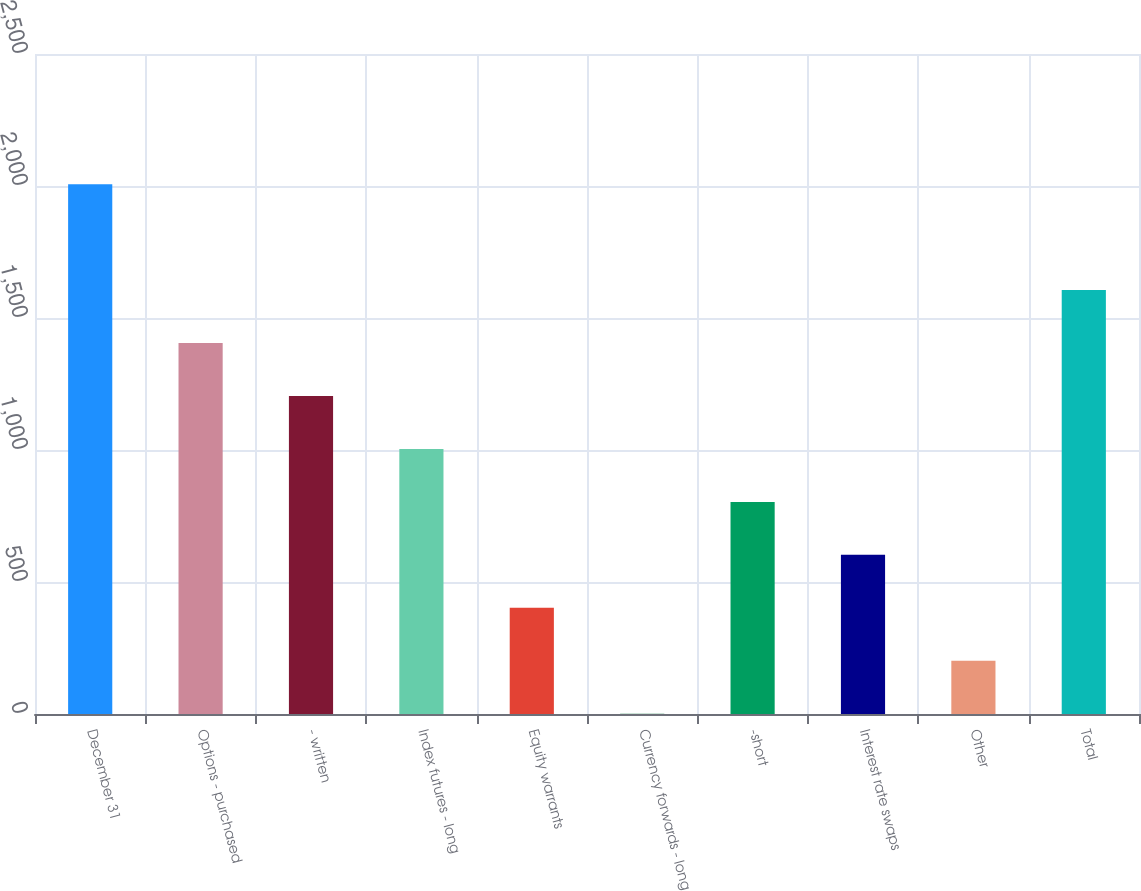Convert chart to OTSL. <chart><loc_0><loc_0><loc_500><loc_500><bar_chart><fcel>December 31<fcel>Options - purchased<fcel>- written<fcel>Index futures - long<fcel>Equity warrants<fcel>Currency forwards - long<fcel>-short<fcel>Interest rate swaps<fcel>Other<fcel>Total<nl><fcel>2007<fcel>1405.2<fcel>1204.6<fcel>1004<fcel>402.2<fcel>1<fcel>803.4<fcel>602.8<fcel>201.6<fcel>1605.8<nl></chart> 